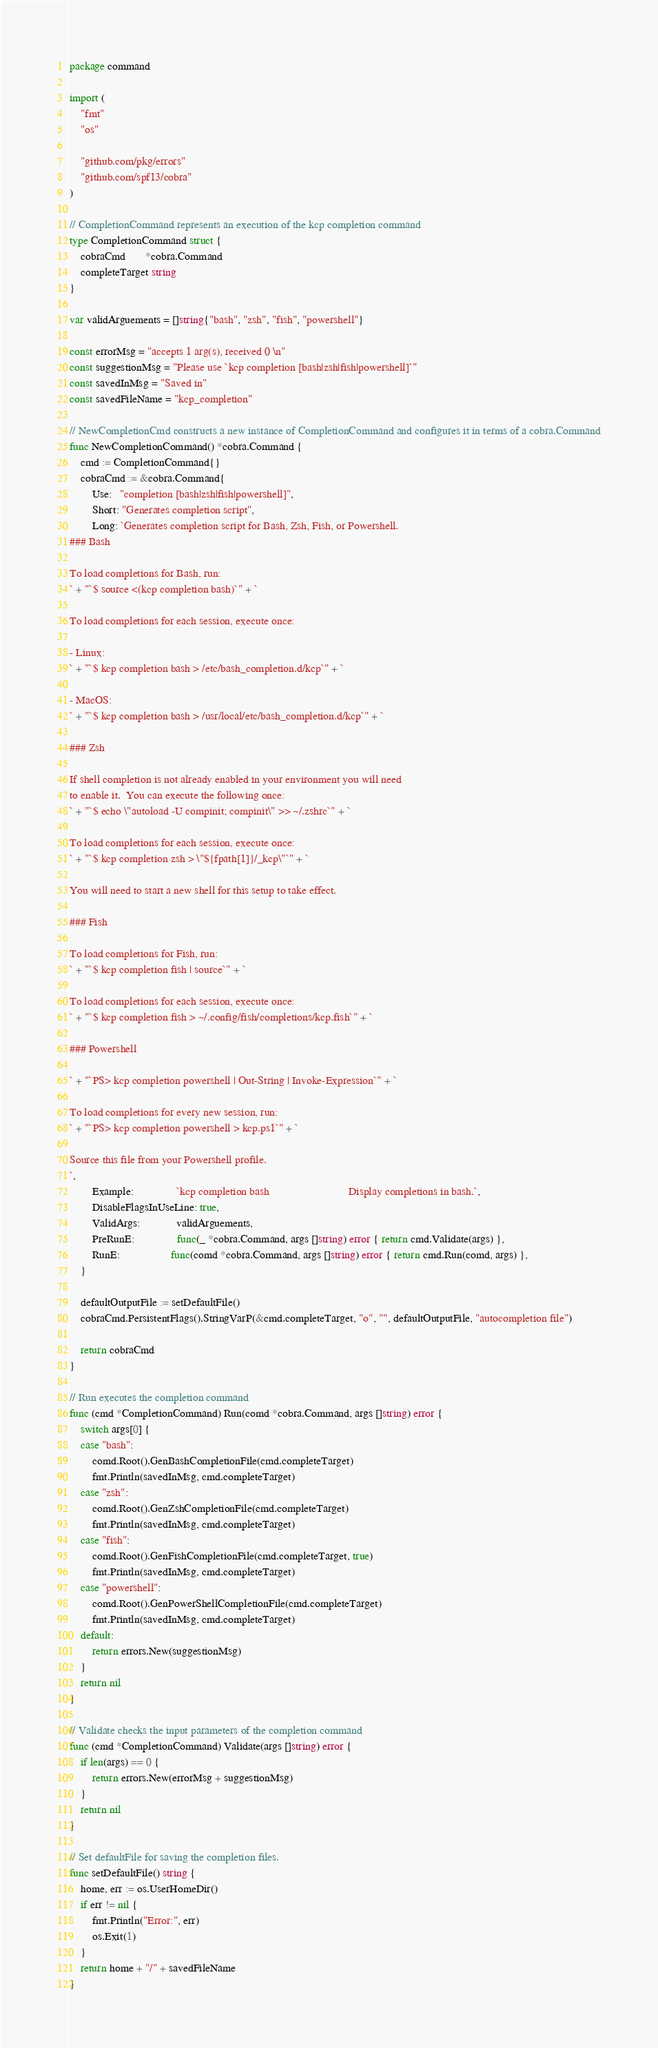<code> <loc_0><loc_0><loc_500><loc_500><_Go_>package command

import (
	"fmt"
	"os"

	"github.com/pkg/errors"
	"github.com/spf13/cobra"
)

// CompletionCommand represents an execution of the kcp completion command
type CompletionCommand struct {
	cobraCmd       *cobra.Command
	completeTarget string
}

var validArguements = []string{"bash", "zsh", "fish", "powershell"}

const errorMsg = "accepts 1 arg(s), received 0 \n"
const suggestionMsg = "Please use `kcp completion [bash|zsh|fish|powershell]`"
const savedInMsg = "Saved in"
const savedFileName = "kcp_completion"

// NewCompletionCmd constructs a new instance of CompletionCommand and configures it in terms of a cobra.Command
func NewCompletionCommand() *cobra.Command {
	cmd := CompletionCommand{}
	cobraCmd := &cobra.Command{
		Use:   "completion [bash|zsh|fish|powershell]",
		Short: "Generates completion script",
		Long: `Generates completion script for Bash, Zsh, Fish, or Powershell.
### Bash

To load completions for Bash, run:
` + "`$ source <(kcp completion bash)`" + `

To load completions for each session, execute once:

- Linux:
` + "`$ kcp completion bash > /etc/bash_completion.d/kcp`" + `

- MacOS:
` + "`$ kcp completion bash > /usr/local/etc/bash_completion.d/kcp`" + `

### Zsh

If shell completion is not already enabled in your environment you will need
to enable it.  You can execute the following once:
` + "`$ echo \"autoload -U compinit; compinit\" >> ~/.zshrc`" + `

To load completions for each session, execute once:
` + "`$ kcp completion zsh > \"${fpath[1]}/_kcp\"`" + `

You will need to start a new shell for this setup to take effect.

### Fish

To load completions for Fish, run:
` + "`$ kcp completion fish | source`" + `

To load completions for each session, execute once:
` + "`$ kcp completion fish > ~/.config/fish/completions/kcp.fish`" + `

### Powershell

` + "`PS> kcp completion powershell | Out-String | Invoke-Expression`" + `

To load completions for every new session, run:
` + "`PS> kcp completion powershell > kcp.ps1`" + `

Source this file from your Powershell profile.
`,
		Example:               `kcp completion bash                            Display completions in bash.`,
		DisableFlagsInUseLine: true,
		ValidArgs:             validArguements,
		PreRunE:               func(_ *cobra.Command, args []string) error { return cmd.Validate(args) },
		RunE:                  func(comd *cobra.Command, args []string) error { return cmd.Run(comd, args) },
	}

	defaultOutputFile := setDefaultFile()
	cobraCmd.PersistentFlags().StringVarP(&cmd.completeTarget, "o", "", defaultOutputFile, "autocompletion file")

	return cobraCmd
}

// Run executes the completion command
func (cmd *CompletionCommand) Run(comd *cobra.Command, args []string) error {
	switch args[0] {
	case "bash":
		comd.Root().GenBashCompletionFile(cmd.completeTarget)
		fmt.Println(savedInMsg, cmd.completeTarget)
	case "zsh":
		comd.Root().GenZshCompletionFile(cmd.completeTarget)
		fmt.Println(savedInMsg, cmd.completeTarget)
	case "fish":
		comd.Root().GenFishCompletionFile(cmd.completeTarget, true)
		fmt.Println(savedInMsg, cmd.completeTarget)
	case "powershell":
		comd.Root().GenPowerShellCompletionFile(cmd.completeTarget)
		fmt.Println(savedInMsg, cmd.completeTarget)
	default:
		return errors.New(suggestionMsg)
	}
	return nil
}

// Validate checks the input parameters of the completion command
func (cmd *CompletionCommand) Validate(args []string) error {
	if len(args) == 0 {
		return errors.New(errorMsg + suggestionMsg)
	}
	return nil
}

// Set defaultFile for saving the completion files.
func setDefaultFile() string {
	home, err := os.UserHomeDir()
	if err != nil {
		fmt.Println("Error:", err)
		os.Exit(1)
	}
	return home + "/" + savedFileName
}
</code> 